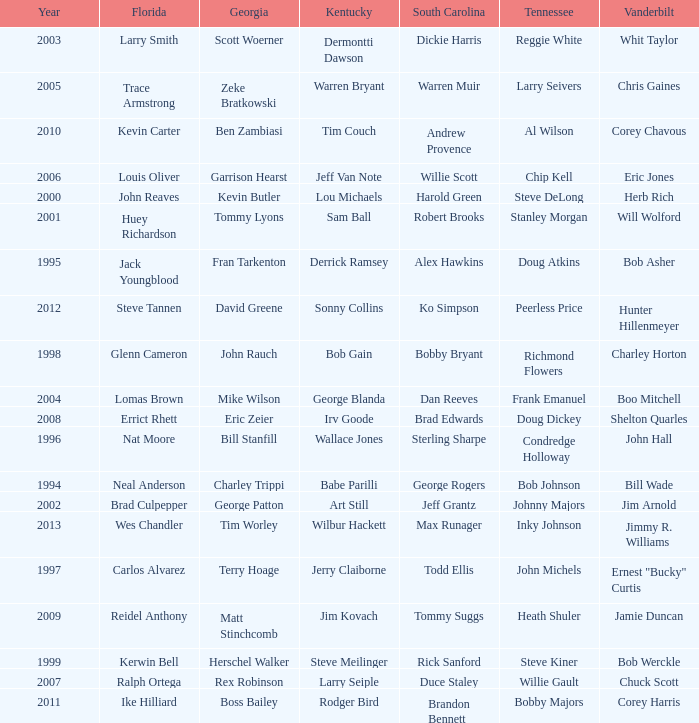What is the total Year of jeff van note ( Kentucky) 2006.0. Write the full table. {'header': ['Year', 'Florida', 'Georgia', 'Kentucky', 'South Carolina', 'Tennessee', 'Vanderbilt'], 'rows': [['2003', 'Larry Smith', 'Scott Woerner', 'Dermontti Dawson', 'Dickie Harris', 'Reggie White', 'Whit Taylor'], ['2005', 'Trace Armstrong', 'Zeke Bratkowski', 'Warren Bryant', 'Warren Muir', 'Larry Seivers', 'Chris Gaines'], ['2010', 'Kevin Carter', 'Ben Zambiasi', 'Tim Couch', 'Andrew Provence', 'Al Wilson', 'Corey Chavous'], ['2006', 'Louis Oliver', 'Garrison Hearst', 'Jeff Van Note', 'Willie Scott', 'Chip Kell', 'Eric Jones'], ['2000', 'John Reaves', 'Kevin Butler', 'Lou Michaels', 'Harold Green', 'Steve DeLong', 'Herb Rich'], ['2001', 'Huey Richardson', 'Tommy Lyons', 'Sam Ball', 'Robert Brooks', 'Stanley Morgan', 'Will Wolford'], ['1995', 'Jack Youngblood', 'Fran Tarkenton', 'Derrick Ramsey', 'Alex Hawkins', 'Doug Atkins', 'Bob Asher'], ['2012', 'Steve Tannen', 'David Greene', 'Sonny Collins', 'Ko Simpson', 'Peerless Price', 'Hunter Hillenmeyer'], ['1998', 'Glenn Cameron', 'John Rauch', 'Bob Gain', 'Bobby Bryant', 'Richmond Flowers', 'Charley Horton'], ['2004', 'Lomas Brown', 'Mike Wilson', 'George Blanda', 'Dan Reeves', 'Frank Emanuel', 'Boo Mitchell'], ['2008', 'Errict Rhett', 'Eric Zeier', 'Irv Goode', 'Brad Edwards', 'Doug Dickey', 'Shelton Quarles'], ['1996', 'Nat Moore', 'Bill Stanfill', 'Wallace Jones', 'Sterling Sharpe', 'Condredge Holloway', 'John Hall'], ['1994', 'Neal Anderson', 'Charley Trippi', 'Babe Parilli', 'George Rogers', 'Bob Johnson', 'Bill Wade'], ['2002', 'Brad Culpepper', 'George Patton', 'Art Still', 'Jeff Grantz', 'Johnny Majors', 'Jim Arnold'], ['2013', 'Wes Chandler', 'Tim Worley', 'Wilbur Hackett', 'Max Runager', 'Inky Johnson', 'Jimmy R. Williams'], ['1997', 'Carlos Alvarez', 'Terry Hoage', 'Jerry Claiborne', 'Todd Ellis', 'John Michels', 'Ernest "Bucky" Curtis'], ['2009', 'Reidel Anthony', 'Matt Stinchcomb', 'Jim Kovach', 'Tommy Suggs', 'Heath Shuler', 'Jamie Duncan'], ['1999', 'Kerwin Bell', 'Herschel Walker', 'Steve Meilinger', 'Rick Sanford', 'Steve Kiner', 'Bob Werckle'], ['2007', 'Ralph Ortega', 'Rex Robinson', 'Larry Seiple', 'Duce Staley', 'Willie Gault', 'Chuck Scott'], ['2011', 'Ike Hilliard', 'Boss Bailey', 'Rodger Bird', 'Brandon Bennett', 'Bobby Majors', 'Corey Harris']]} 